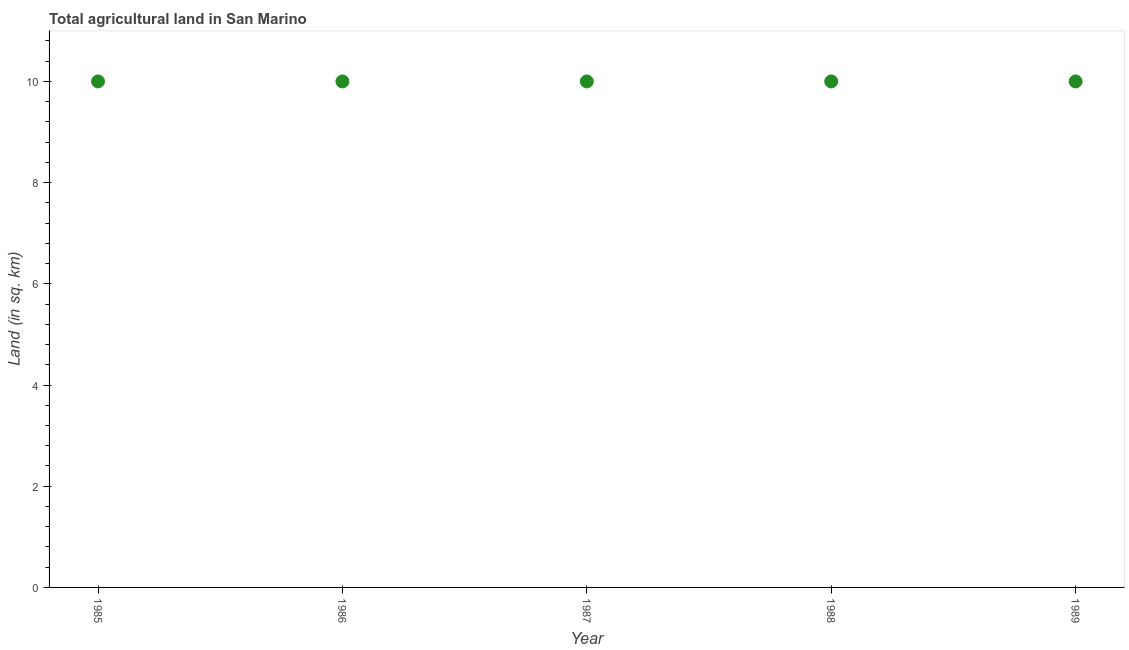What is the agricultural land in 1989?
Keep it short and to the point. 10. Across all years, what is the maximum agricultural land?
Ensure brevity in your answer.  10. Across all years, what is the minimum agricultural land?
Offer a very short reply. 10. In which year was the agricultural land maximum?
Keep it short and to the point. 1985. What is the sum of the agricultural land?
Offer a terse response. 50. In how many years, is the agricultural land greater than 9.6 sq. km?
Ensure brevity in your answer.  5. Do a majority of the years between 1987 and 1989 (inclusive) have agricultural land greater than 2 sq. km?
Your answer should be compact. Yes. What is the difference between the highest and the second highest agricultural land?
Ensure brevity in your answer.  0. Is the sum of the agricultural land in 1985 and 1988 greater than the maximum agricultural land across all years?
Offer a very short reply. Yes. What is the difference between the highest and the lowest agricultural land?
Provide a short and direct response. 0. How many dotlines are there?
Your answer should be very brief. 1. What is the difference between two consecutive major ticks on the Y-axis?
Make the answer very short. 2. Does the graph contain grids?
Your answer should be compact. No. What is the title of the graph?
Provide a short and direct response. Total agricultural land in San Marino. What is the label or title of the Y-axis?
Keep it short and to the point. Land (in sq. km). What is the Land (in sq. km) in 1985?
Provide a short and direct response. 10. What is the Land (in sq. km) in 1986?
Offer a terse response. 10. What is the Land (in sq. km) in 1988?
Give a very brief answer. 10. What is the difference between the Land (in sq. km) in 1985 and 1987?
Your response must be concise. 0. What is the difference between the Land (in sq. km) in 1985 and 1988?
Provide a succinct answer. 0. What is the difference between the Land (in sq. km) in 1985 and 1989?
Offer a very short reply. 0. What is the difference between the Land (in sq. km) in 1987 and 1989?
Keep it short and to the point. 0. What is the difference between the Land (in sq. km) in 1988 and 1989?
Provide a short and direct response. 0. What is the ratio of the Land (in sq. km) in 1985 to that in 1988?
Ensure brevity in your answer.  1. What is the ratio of the Land (in sq. km) in 1986 to that in 1987?
Ensure brevity in your answer.  1. What is the ratio of the Land (in sq. km) in 1986 to that in 1988?
Your answer should be compact. 1. 